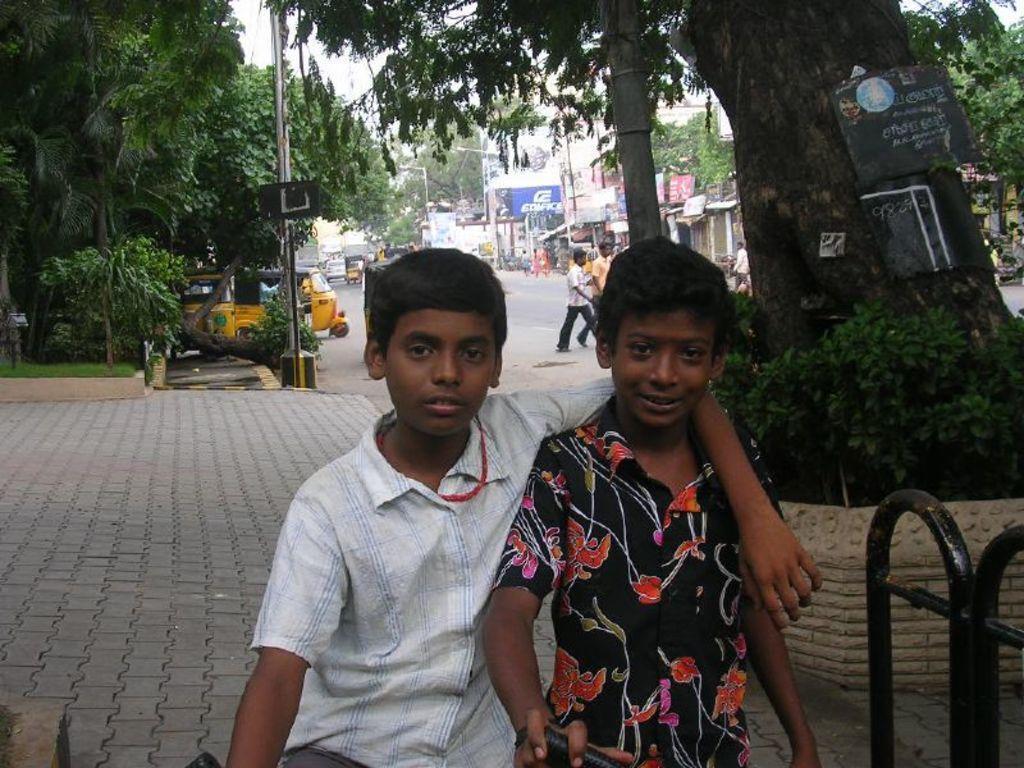Could you give a brief overview of what you see in this image? In this picture there are two people in the foreground. At the back there are buildings and trees and poles and there are vehicles on the road and there are group of people walking on the road. At the top there is sky. At the bottom there is a road and there is a pavement and there is grass. On the right side of the image there is a railing and there are boards on the tree and there is text on the boards. 